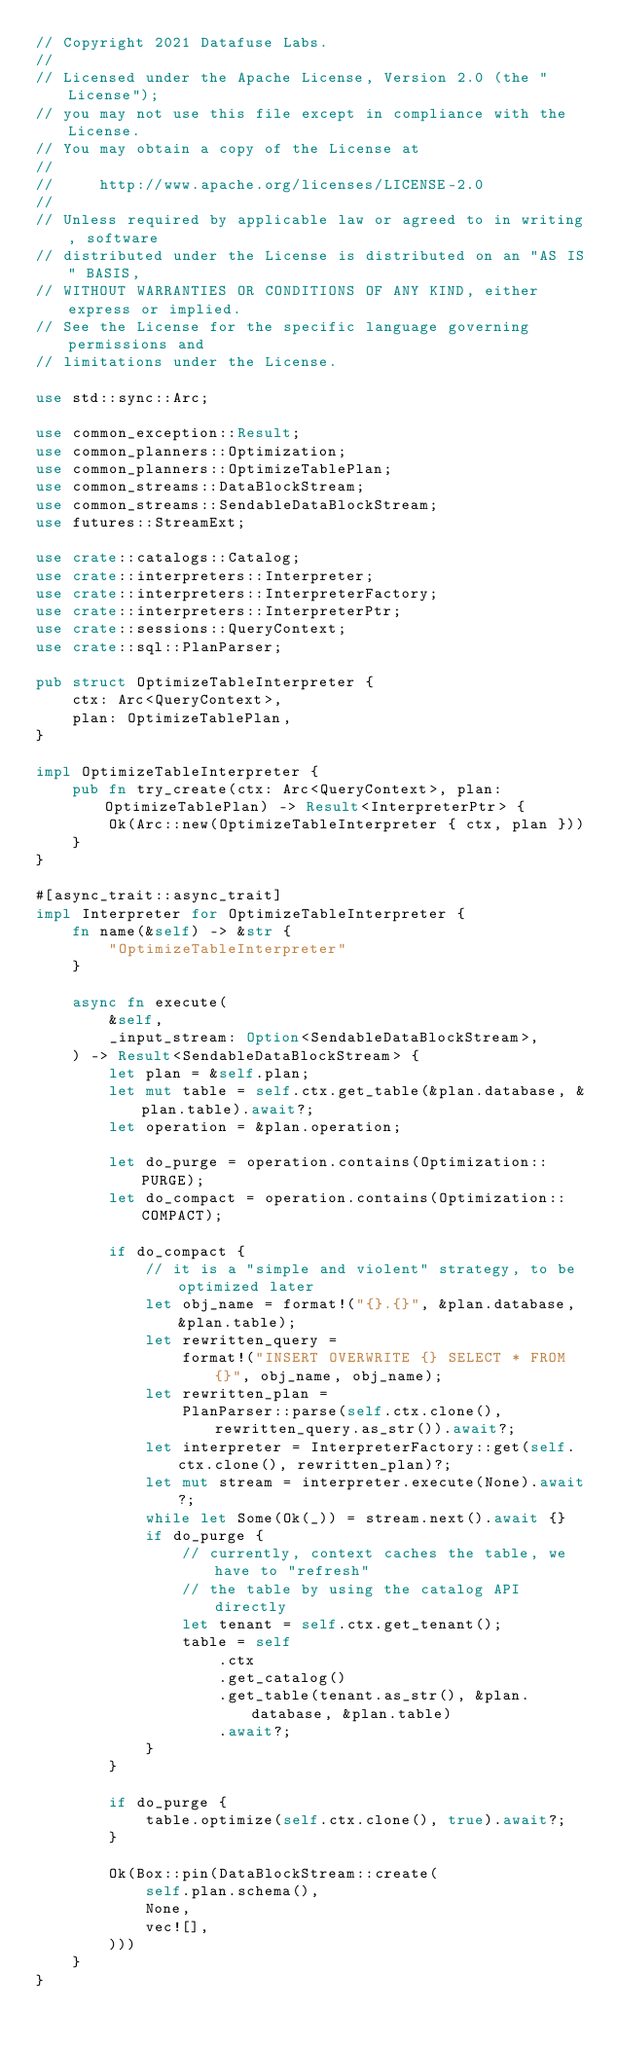Convert code to text. <code><loc_0><loc_0><loc_500><loc_500><_Rust_>// Copyright 2021 Datafuse Labs.
//
// Licensed under the Apache License, Version 2.0 (the "License");
// you may not use this file except in compliance with the License.
// You may obtain a copy of the License at
//
//     http://www.apache.org/licenses/LICENSE-2.0
//
// Unless required by applicable law or agreed to in writing, software
// distributed under the License is distributed on an "AS IS" BASIS,
// WITHOUT WARRANTIES OR CONDITIONS OF ANY KIND, either express or implied.
// See the License for the specific language governing permissions and
// limitations under the License.

use std::sync::Arc;

use common_exception::Result;
use common_planners::Optimization;
use common_planners::OptimizeTablePlan;
use common_streams::DataBlockStream;
use common_streams::SendableDataBlockStream;
use futures::StreamExt;

use crate::catalogs::Catalog;
use crate::interpreters::Interpreter;
use crate::interpreters::InterpreterFactory;
use crate::interpreters::InterpreterPtr;
use crate::sessions::QueryContext;
use crate::sql::PlanParser;

pub struct OptimizeTableInterpreter {
    ctx: Arc<QueryContext>,
    plan: OptimizeTablePlan,
}

impl OptimizeTableInterpreter {
    pub fn try_create(ctx: Arc<QueryContext>, plan: OptimizeTablePlan) -> Result<InterpreterPtr> {
        Ok(Arc::new(OptimizeTableInterpreter { ctx, plan }))
    }
}

#[async_trait::async_trait]
impl Interpreter for OptimizeTableInterpreter {
    fn name(&self) -> &str {
        "OptimizeTableInterpreter"
    }

    async fn execute(
        &self,
        _input_stream: Option<SendableDataBlockStream>,
    ) -> Result<SendableDataBlockStream> {
        let plan = &self.plan;
        let mut table = self.ctx.get_table(&plan.database, &plan.table).await?;
        let operation = &plan.operation;

        let do_purge = operation.contains(Optimization::PURGE);
        let do_compact = operation.contains(Optimization::COMPACT);

        if do_compact {
            // it is a "simple and violent" strategy, to be optimized later
            let obj_name = format!("{}.{}", &plan.database, &plan.table);
            let rewritten_query =
                format!("INSERT OVERWRITE {} SELECT * FROM {}", obj_name, obj_name);
            let rewritten_plan =
                PlanParser::parse(self.ctx.clone(), rewritten_query.as_str()).await?;
            let interpreter = InterpreterFactory::get(self.ctx.clone(), rewritten_plan)?;
            let mut stream = interpreter.execute(None).await?;
            while let Some(Ok(_)) = stream.next().await {}
            if do_purge {
                // currently, context caches the table, we have to "refresh"
                // the table by using the catalog API directly
                let tenant = self.ctx.get_tenant();
                table = self
                    .ctx
                    .get_catalog()
                    .get_table(tenant.as_str(), &plan.database, &plan.table)
                    .await?;
            }
        }

        if do_purge {
            table.optimize(self.ctx.clone(), true).await?;
        }

        Ok(Box::pin(DataBlockStream::create(
            self.plan.schema(),
            None,
            vec![],
        )))
    }
}
</code> 